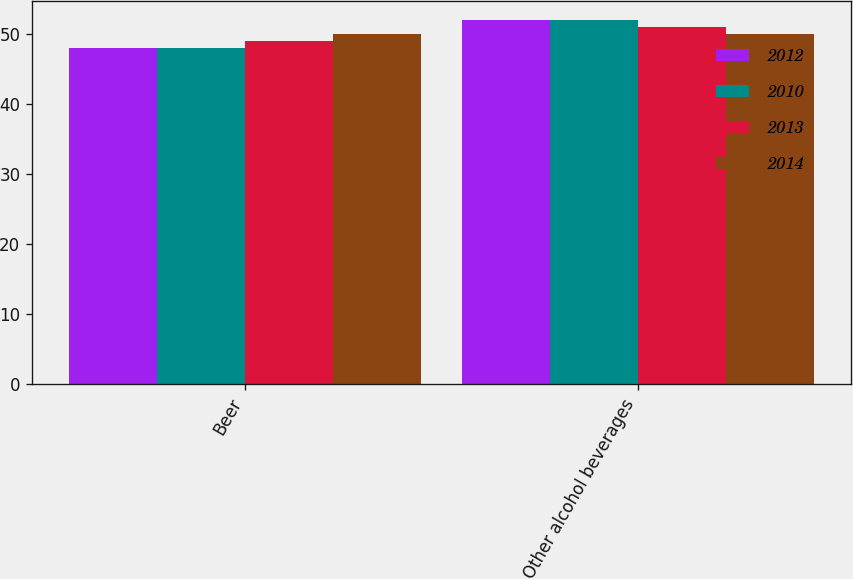Convert chart to OTSL. <chart><loc_0><loc_0><loc_500><loc_500><stacked_bar_chart><ecel><fcel>Beer<fcel>Other alcohol beverages<nl><fcel>2012<fcel>48<fcel>52<nl><fcel>2010<fcel>48<fcel>52<nl><fcel>2013<fcel>49<fcel>51<nl><fcel>2014<fcel>50<fcel>50<nl></chart> 